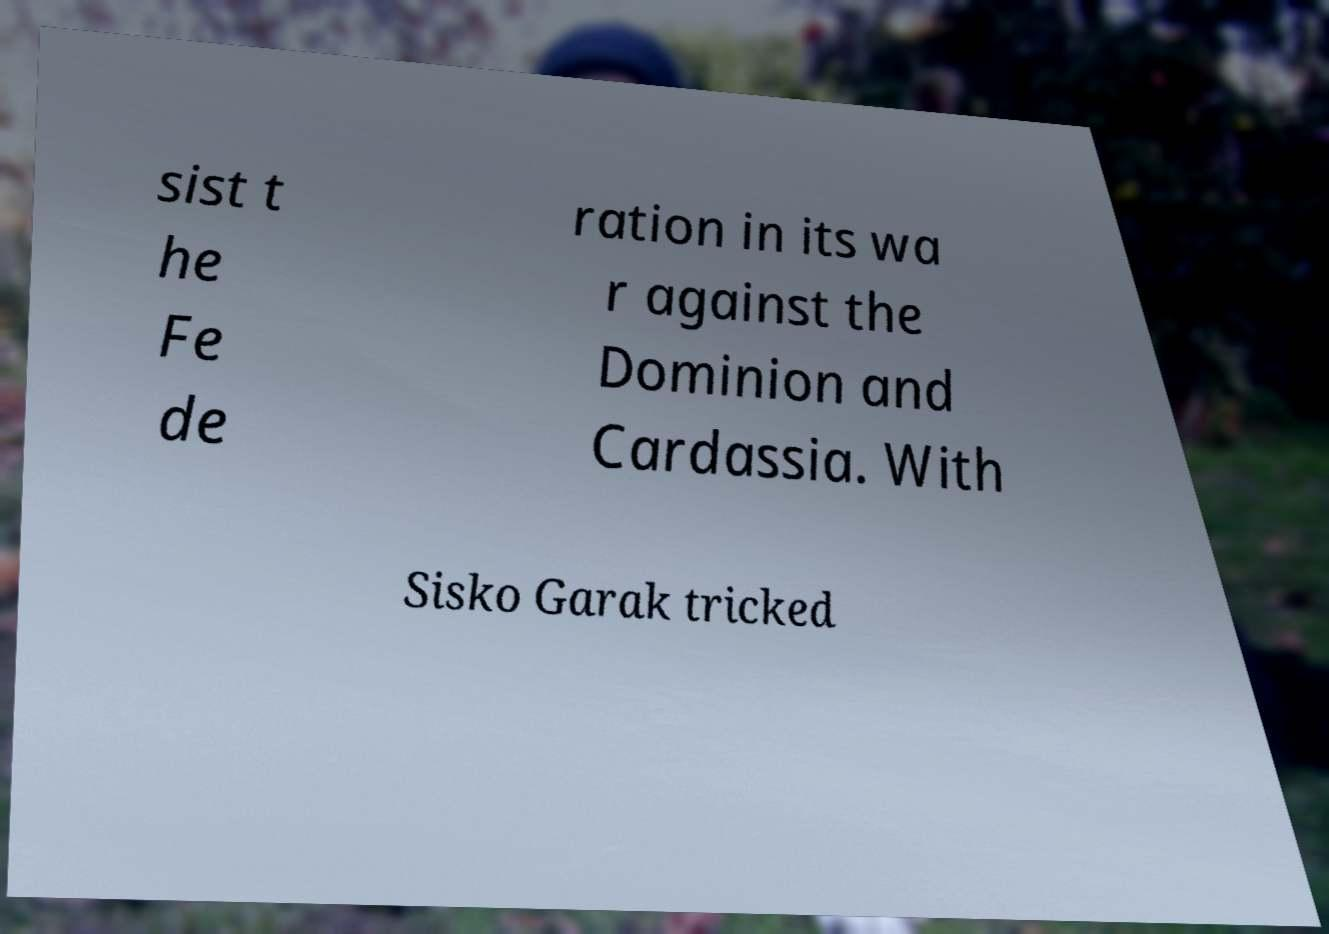Please identify and transcribe the text found in this image. sist t he Fe de ration in its wa r against the Dominion and Cardassia. With Sisko Garak tricked 